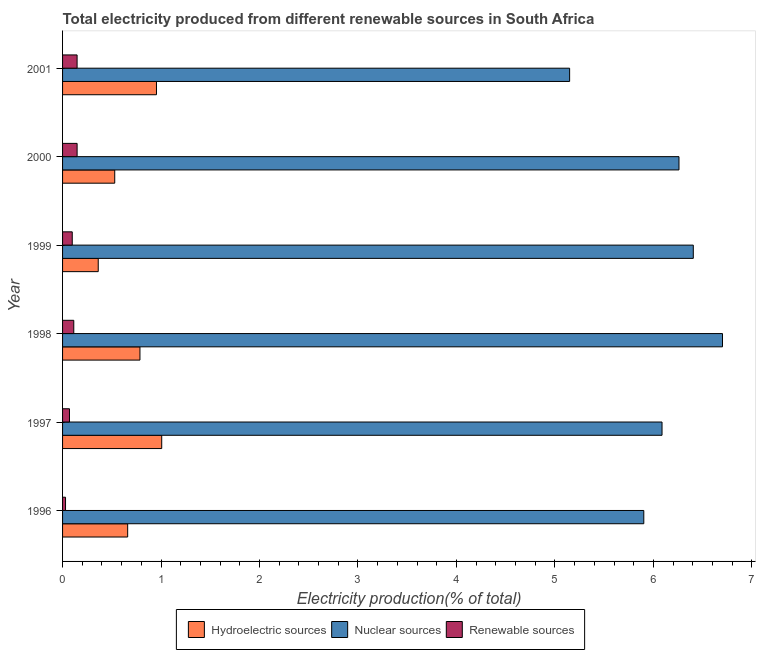How many different coloured bars are there?
Provide a succinct answer. 3. How many groups of bars are there?
Your response must be concise. 6. Are the number of bars per tick equal to the number of legend labels?
Provide a succinct answer. Yes. Are the number of bars on each tick of the Y-axis equal?
Provide a succinct answer. Yes. How many bars are there on the 4th tick from the top?
Provide a succinct answer. 3. What is the percentage of electricity produced by renewable sources in 1999?
Offer a very short reply. 0.1. Across all years, what is the maximum percentage of electricity produced by renewable sources?
Offer a terse response. 0.15. Across all years, what is the minimum percentage of electricity produced by renewable sources?
Offer a terse response. 0.03. In which year was the percentage of electricity produced by renewable sources minimum?
Keep it short and to the point. 1996. What is the total percentage of electricity produced by nuclear sources in the graph?
Your answer should be very brief. 36.51. What is the difference between the percentage of electricity produced by nuclear sources in 1998 and that in 2000?
Ensure brevity in your answer.  0.44. What is the difference between the percentage of electricity produced by renewable sources in 1997 and the percentage of electricity produced by hydroelectric sources in 1999?
Your response must be concise. -0.29. What is the average percentage of electricity produced by renewable sources per year?
Keep it short and to the point. 0.1. In the year 2000, what is the difference between the percentage of electricity produced by nuclear sources and percentage of electricity produced by renewable sources?
Ensure brevity in your answer.  6.11. What is the ratio of the percentage of electricity produced by hydroelectric sources in 1996 to that in 2000?
Offer a terse response. 1.25. Is the difference between the percentage of electricity produced by hydroelectric sources in 1996 and 1998 greater than the difference between the percentage of electricity produced by nuclear sources in 1996 and 1998?
Make the answer very short. Yes. What is the difference between the highest and the second highest percentage of electricity produced by hydroelectric sources?
Keep it short and to the point. 0.05. What is the difference between the highest and the lowest percentage of electricity produced by renewable sources?
Keep it short and to the point. 0.12. What does the 2nd bar from the top in 1997 represents?
Keep it short and to the point. Nuclear sources. What does the 1st bar from the bottom in 1997 represents?
Your answer should be compact. Hydroelectric sources. Is it the case that in every year, the sum of the percentage of electricity produced by hydroelectric sources and percentage of electricity produced by nuclear sources is greater than the percentage of electricity produced by renewable sources?
Offer a very short reply. Yes. What is the difference between two consecutive major ticks on the X-axis?
Keep it short and to the point. 1. Are the values on the major ticks of X-axis written in scientific E-notation?
Provide a succinct answer. No. How are the legend labels stacked?
Offer a very short reply. Horizontal. What is the title of the graph?
Provide a short and direct response. Total electricity produced from different renewable sources in South Africa. What is the label or title of the X-axis?
Provide a succinct answer. Electricity production(% of total). What is the label or title of the Y-axis?
Make the answer very short. Year. What is the Electricity production(% of total) of Hydroelectric sources in 1996?
Your response must be concise. 0.66. What is the Electricity production(% of total) in Nuclear sources in 1996?
Offer a terse response. 5.9. What is the Electricity production(% of total) in Renewable sources in 1996?
Keep it short and to the point. 0.03. What is the Electricity production(% of total) in Hydroelectric sources in 1997?
Make the answer very short. 1.01. What is the Electricity production(% of total) of Nuclear sources in 1997?
Your answer should be compact. 6.09. What is the Electricity production(% of total) in Renewable sources in 1997?
Your answer should be compact. 0.07. What is the Electricity production(% of total) in Hydroelectric sources in 1998?
Offer a very short reply. 0.79. What is the Electricity production(% of total) of Nuclear sources in 1998?
Provide a short and direct response. 6.7. What is the Electricity production(% of total) of Renewable sources in 1998?
Offer a terse response. 0.11. What is the Electricity production(% of total) of Hydroelectric sources in 1999?
Provide a succinct answer. 0.36. What is the Electricity production(% of total) of Nuclear sources in 1999?
Provide a short and direct response. 6.4. What is the Electricity production(% of total) of Renewable sources in 1999?
Keep it short and to the point. 0.1. What is the Electricity production(% of total) in Hydroelectric sources in 2000?
Offer a terse response. 0.53. What is the Electricity production(% of total) of Nuclear sources in 2000?
Offer a terse response. 6.26. What is the Electricity production(% of total) in Renewable sources in 2000?
Provide a short and direct response. 0.15. What is the Electricity production(% of total) of Hydroelectric sources in 2001?
Your answer should be very brief. 0.95. What is the Electricity production(% of total) in Nuclear sources in 2001?
Give a very brief answer. 5.15. What is the Electricity production(% of total) of Renewable sources in 2001?
Your answer should be very brief. 0.15. Across all years, what is the maximum Electricity production(% of total) in Hydroelectric sources?
Provide a succinct answer. 1.01. Across all years, what is the maximum Electricity production(% of total) of Nuclear sources?
Your answer should be very brief. 6.7. Across all years, what is the maximum Electricity production(% of total) in Renewable sources?
Provide a succinct answer. 0.15. Across all years, what is the minimum Electricity production(% of total) of Hydroelectric sources?
Offer a very short reply. 0.36. Across all years, what is the minimum Electricity production(% of total) in Nuclear sources?
Make the answer very short. 5.15. Across all years, what is the minimum Electricity production(% of total) in Renewable sources?
Give a very brief answer. 0.03. What is the total Electricity production(% of total) of Hydroelectric sources in the graph?
Your response must be concise. 4.3. What is the total Electricity production(% of total) of Nuclear sources in the graph?
Offer a very short reply. 36.51. What is the total Electricity production(% of total) of Renewable sources in the graph?
Make the answer very short. 0.61. What is the difference between the Electricity production(% of total) in Hydroelectric sources in 1996 and that in 1997?
Provide a succinct answer. -0.35. What is the difference between the Electricity production(% of total) of Nuclear sources in 1996 and that in 1997?
Provide a succinct answer. -0.19. What is the difference between the Electricity production(% of total) in Renewable sources in 1996 and that in 1997?
Keep it short and to the point. -0.04. What is the difference between the Electricity production(% of total) in Hydroelectric sources in 1996 and that in 1998?
Your response must be concise. -0.12. What is the difference between the Electricity production(% of total) in Nuclear sources in 1996 and that in 1998?
Give a very brief answer. -0.8. What is the difference between the Electricity production(% of total) in Renewable sources in 1996 and that in 1998?
Your answer should be compact. -0.08. What is the difference between the Electricity production(% of total) in Hydroelectric sources in 1996 and that in 1999?
Make the answer very short. 0.3. What is the difference between the Electricity production(% of total) in Nuclear sources in 1996 and that in 1999?
Make the answer very short. -0.5. What is the difference between the Electricity production(% of total) in Renewable sources in 1996 and that in 1999?
Your answer should be very brief. -0.07. What is the difference between the Electricity production(% of total) of Hydroelectric sources in 1996 and that in 2000?
Make the answer very short. 0.13. What is the difference between the Electricity production(% of total) in Nuclear sources in 1996 and that in 2000?
Offer a terse response. -0.36. What is the difference between the Electricity production(% of total) of Renewable sources in 1996 and that in 2000?
Your response must be concise. -0.12. What is the difference between the Electricity production(% of total) in Hydroelectric sources in 1996 and that in 2001?
Your answer should be very brief. -0.29. What is the difference between the Electricity production(% of total) in Nuclear sources in 1996 and that in 2001?
Provide a succinct answer. 0.75. What is the difference between the Electricity production(% of total) of Renewable sources in 1996 and that in 2001?
Offer a very short reply. -0.12. What is the difference between the Electricity production(% of total) of Hydroelectric sources in 1997 and that in 1998?
Provide a short and direct response. 0.22. What is the difference between the Electricity production(% of total) in Nuclear sources in 1997 and that in 1998?
Keep it short and to the point. -0.61. What is the difference between the Electricity production(% of total) of Renewable sources in 1997 and that in 1998?
Your answer should be compact. -0.04. What is the difference between the Electricity production(% of total) of Hydroelectric sources in 1997 and that in 1999?
Keep it short and to the point. 0.64. What is the difference between the Electricity production(% of total) of Nuclear sources in 1997 and that in 1999?
Provide a succinct answer. -0.32. What is the difference between the Electricity production(% of total) of Renewable sources in 1997 and that in 1999?
Provide a short and direct response. -0.03. What is the difference between the Electricity production(% of total) of Hydroelectric sources in 1997 and that in 2000?
Provide a succinct answer. 0.48. What is the difference between the Electricity production(% of total) of Nuclear sources in 1997 and that in 2000?
Ensure brevity in your answer.  -0.17. What is the difference between the Electricity production(% of total) in Renewable sources in 1997 and that in 2000?
Offer a terse response. -0.08. What is the difference between the Electricity production(% of total) of Hydroelectric sources in 1997 and that in 2001?
Give a very brief answer. 0.05. What is the difference between the Electricity production(% of total) of Nuclear sources in 1997 and that in 2001?
Your answer should be very brief. 0.94. What is the difference between the Electricity production(% of total) of Renewable sources in 1997 and that in 2001?
Offer a terse response. -0.08. What is the difference between the Electricity production(% of total) in Hydroelectric sources in 1998 and that in 1999?
Offer a terse response. 0.42. What is the difference between the Electricity production(% of total) in Nuclear sources in 1998 and that in 1999?
Give a very brief answer. 0.3. What is the difference between the Electricity production(% of total) of Renewable sources in 1998 and that in 1999?
Ensure brevity in your answer.  0.02. What is the difference between the Electricity production(% of total) of Hydroelectric sources in 1998 and that in 2000?
Your response must be concise. 0.26. What is the difference between the Electricity production(% of total) in Nuclear sources in 1998 and that in 2000?
Your response must be concise. 0.44. What is the difference between the Electricity production(% of total) in Renewable sources in 1998 and that in 2000?
Your response must be concise. -0.03. What is the difference between the Electricity production(% of total) in Hydroelectric sources in 1998 and that in 2001?
Offer a very short reply. -0.17. What is the difference between the Electricity production(% of total) in Nuclear sources in 1998 and that in 2001?
Give a very brief answer. 1.55. What is the difference between the Electricity production(% of total) in Renewable sources in 1998 and that in 2001?
Your answer should be compact. -0.03. What is the difference between the Electricity production(% of total) in Hydroelectric sources in 1999 and that in 2000?
Your answer should be very brief. -0.17. What is the difference between the Electricity production(% of total) in Nuclear sources in 1999 and that in 2000?
Offer a terse response. 0.15. What is the difference between the Electricity production(% of total) in Renewable sources in 1999 and that in 2000?
Keep it short and to the point. -0.05. What is the difference between the Electricity production(% of total) of Hydroelectric sources in 1999 and that in 2001?
Offer a terse response. -0.59. What is the difference between the Electricity production(% of total) in Nuclear sources in 1999 and that in 2001?
Give a very brief answer. 1.26. What is the difference between the Electricity production(% of total) in Renewable sources in 1999 and that in 2001?
Your answer should be compact. -0.05. What is the difference between the Electricity production(% of total) of Hydroelectric sources in 2000 and that in 2001?
Keep it short and to the point. -0.42. What is the difference between the Electricity production(% of total) of Nuclear sources in 2000 and that in 2001?
Offer a terse response. 1.11. What is the difference between the Electricity production(% of total) of Renewable sources in 2000 and that in 2001?
Your response must be concise. 0. What is the difference between the Electricity production(% of total) in Hydroelectric sources in 1996 and the Electricity production(% of total) in Nuclear sources in 1997?
Your response must be concise. -5.43. What is the difference between the Electricity production(% of total) in Hydroelectric sources in 1996 and the Electricity production(% of total) in Renewable sources in 1997?
Your answer should be very brief. 0.59. What is the difference between the Electricity production(% of total) in Nuclear sources in 1996 and the Electricity production(% of total) in Renewable sources in 1997?
Your answer should be very brief. 5.83. What is the difference between the Electricity production(% of total) of Hydroelectric sources in 1996 and the Electricity production(% of total) of Nuclear sources in 1998?
Provide a succinct answer. -6.04. What is the difference between the Electricity production(% of total) in Hydroelectric sources in 1996 and the Electricity production(% of total) in Renewable sources in 1998?
Provide a succinct answer. 0.55. What is the difference between the Electricity production(% of total) of Nuclear sources in 1996 and the Electricity production(% of total) of Renewable sources in 1998?
Provide a short and direct response. 5.79. What is the difference between the Electricity production(% of total) in Hydroelectric sources in 1996 and the Electricity production(% of total) in Nuclear sources in 1999?
Make the answer very short. -5.74. What is the difference between the Electricity production(% of total) of Hydroelectric sources in 1996 and the Electricity production(% of total) of Renewable sources in 1999?
Your answer should be compact. 0.56. What is the difference between the Electricity production(% of total) of Nuclear sources in 1996 and the Electricity production(% of total) of Renewable sources in 1999?
Provide a short and direct response. 5.8. What is the difference between the Electricity production(% of total) of Hydroelectric sources in 1996 and the Electricity production(% of total) of Nuclear sources in 2000?
Your answer should be compact. -5.6. What is the difference between the Electricity production(% of total) of Hydroelectric sources in 1996 and the Electricity production(% of total) of Renewable sources in 2000?
Your response must be concise. 0.51. What is the difference between the Electricity production(% of total) in Nuclear sources in 1996 and the Electricity production(% of total) in Renewable sources in 2000?
Offer a very short reply. 5.75. What is the difference between the Electricity production(% of total) in Hydroelectric sources in 1996 and the Electricity production(% of total) in Nuclear sources in 2001?
Your response must be concise. -4.49. What is the difference between the Electricity production(% of total) of Hydroelectric sources in 1996 and the Electricity production(% of total) of Renewable sources in 2001?
Keep it short and to the point. 0.51. What is the difference between the Electricity production(% of total) in Nuclear sources in 1996 and the Electricity production(% of total) in Renewable sources in 2001?
Offer a terse response. 5.75. What is the difference between the Electricity production(% of total) in Hydroelectric sources in 1997 and the Electricity production(% of total) in Nuclear sources in 1998?
Ensure brevity in your answer.  -5.69. What is the difference between the Electricity production(% of total) of Hydroelectric sources in 1997 and the Electricity production(% of total) of Renewable sources in 1998?
Make the answer very short. 0.89. What is the difference between the Electricity production(% of total) in Nuclear sources in 1997 and the Electricity production(% of total) in Renewable sources in 1998?
Your answer should be compact. 5.97. What is the difference between the Electricity production(% of total) in Hydroelectric sources in 1997 and the Electricity production(% of total) in Nuclear sources in 1999?
Give a very brief answer. -5.4. What is the difference between the Electricity production(% of total) in Hydroelectric sources in 1997 and the Electricity production(% of total) in Renewable sources in 1999?
Offer a very short reply. 0.91. What is the difference between the Electricity production(% of total) in Nuclear sources in 1997 and the Electricity production(% of total) in Renewable sources in 1999?
Provide a short and direct response. 5.99. What is the difference between the Electricity production(% of total) of Hydroelectric sources in 1997 and the Electricity production(% of total) of Nuclear sources in 2000?
Provide a succinct answer. -5.25. What is the difference between the Electricity production(% of total) in Hydroelectric sources in 1997 and the Electricity production(% of total) in Renewable sources in 2000?
Your answer should be very brief. 0.86. What is the difference between the Electricity production(% of total) of Nuclear sources in 1997 and the Electricity production(% of total) of Renewable sources in 2000?
Give a very brief answer. 5.94. What is the difference between the Electricity production(% of total) of Hydroelectric sources in 1997 and the Electricity production(% of total) of Nuclear sources in 2001?
Keep it short and to the point. -4.14. What is the difference between the Electricity production(% of total) in Hydroelectric sources in 1997 and the Electricity production(% of total) in Renewable sources in 2001?
Make the answer very short. 0.86. What is the difference between the Electricity production(% of total) in Nuclear sources in 1997 and the Electricity production(% of total) in Renewable sources in 2001?
Make the answer very short. 5.94. What is the difference between the Electricity production(% of total) in Hydroelectric sources in 1998 and the Electricity production(% of total) in Nuclear sources in 1999?
Ensure brevity in your answer.  -5.62. What is the difference between the Electricity production(% of total) in Hydroelectric sources in 1998 and the Electricity production(% of total) in Renewable sources in 1999?
Your answer should be compact. 0.69. What is the difference between the Electricity production(% of total) of Nuclear sources in 1998 and the Electricity production(% of total) of Renewable sources in 1999?
Provide a short and direct response. 6.6. What is the difference between the Electricity production(% of total) in Hydroelectric sources in 1998 and the Electricity production(% of total) in Nuclear sources in 2000?
Ensure brevity in your answer.  -5.47. What is the difference between the Electricity production(% of total) of Hydroelectric sources in 1998 and the Electricity production(% of total) of Renewable sources in 2000?
Give a very brief answer. 0.64. What is the difference between the Electricity production(% of total) of Nuclear sources in 1998 and the Electricity production(% of total) of Renewable sources in 2000?
Keep it short and to the point. 6.55. What is the difference between the Electricity production(% of total) in Hydroelectric sources in 1998 and the Electricity production(% of total) in Nuclear sources in 2001?
Ensure brevity in your answer.  -4.36. What is the difference between the Electricity production(% of total) of Hydroelectric sources in 1998 and the Electricity production(% of total) of Renewable sources in 2001?
Your answer should be compact. 0.64. What is the difference between the Electricity production(% of total) in Nuclear sources in 1998 and the Electricity production(% of total) in Renewable sources in 2001?
Your response must be concise. 6.55. What is the difference between the Electricity production(% of total) in Hydroelectric sources in 1999 and the Electricity production(% of total) in Nuclear sources in 2000?
Your answer should be compact. -5.9. What is the difference between the Electricity production(% of total) in Hydroelectric sources in 1999 and the Electricity production(% of total) in Renewable sources in 2000?
Your answer should be very brief. 0.21. What is the difference between the Electricity production(% of total) of Nuclear sources in 1999 and the Electricity production(% of total) of Renewable sources in 2000?
Make the answer very short. 6.26. What is the difference between the Electricity production(% of total) of Hydroelectric sources in 1999 and the Electricity production(% of total) of Nuclear sources in 2001?
Keep it short and to the point. -4.79. What is the difference between the Electricity production(% of total) in Hydroelectric sources in 1999 and the Electricity production(% of total) in Renewable sources in 2001?
Keep it short and to the point. 0.21. What is the difference between the Electricity production(% of total) in Nuclear sources in 1999 and the Electricity production(% of total) in Renewable sources in 2001?
Offer a terse response. 6.26. What is the difference between the Electricity production(% of total) of Hydroelectric sources in 2000 and the Electricity production(% of total) of Nuclear sources in 2001?
Offer a very short reply. -4.62. What is the difference between the Electricity production(% of total) in Hydroelectric sources in 2000 and the Electricity production(% of total) in Renewable sources in 2001?
Make the answer very short. 0.38. What is the difference between the Electricity production(% of total) of Nuclear sources in 2000 and the Electricity production(% of total) of Renewable sources in 2001?
Provide a succinct answer. 6.11. What is the average Electricity production(% of total) of Hydroelectric sources per year?
Make the answer very short. 0.72. What is the average Electricity production(% of total) of Nuclear sources per year?
Give a very brief answer. 6.08. What is the average Electricity production(% of total) of Renewable sources per year?
Offer a terse response. 0.1. In the year 1996, what is the difference between the Electricity production(% of total) of Hydroelectric sources and Electricity production(% of total) of Nuclear sources?
Provide a succinct answer. -5.24. In the year 1996, what is the difference between the Electricity production(% of total) of Hydroelectric sources and Electricity production(% of total) of Renewable sources?
Provide a short and direct response. 0.63. In the year 1996, what is the difference between the Electricity production(% of total) of Nuclear sources and Electricity production(% of total) of Renewable sources?
Give a very brief answer. 5.87. In the year 1997, what is the difference between the Electricity production(% of total) of Hydroelectric sources and Electricity production(% of total) of Nuclear sources?
Provide a succinct answer. -5.08. In the year 1997, what is the difference between the Electricity production(% of total) of Hydroelectric sources and Electricity production(% of total) of Renewable sources?
Your answer should be very brief. 0.94. In the year 1997, what is the difference between the Electricity production(% of total) in Nuclear sources and Electricity production(% of total) in Renewable sources?
Offer a terse response. 6.02. In the year 1998, what is the difference between the Electricity production(% of total) of Hydroelectric sources and Electricity production(% of total) of Nuclear sources?
Give a very brief answer. -5.92. In the year 1998, what is the difference between the Electricity production(% of total) of Hydroelectric sources and Electricity production(% of total) of Renewable sources?
Ensure brevity in your answer.  0.67. In the year 1998, what is the difference between the Electricity production(% of total) in Nuclear sources and Electricity production(% of total) in Renewable sources?
Provide a short and direct response. 6.59. In the year 1999, what is the difference between the Electricity production(% of total) in Hydroelectric sources and Electricity production(% of total) in Nuclear sources?
Offer a very short reply. -6.04. In the year 1999, what is the difference between the Electricity production(% of total) in Hydroelectric sources and Electricity production(% of total) in Renewable sources?
Your answer should be very brief. 0.26. In the year 1999, what is the difference between the Electricity production(% of total) in Nuclear sources and Electricity production(% of total) in Renewable sources?
Offer a very short reply. 6.31. In the year 2000, what is the difference between the Electricity production(% of total) in Hydroelectric sources and Electricity production(% of total) in Nuclear sources?
Your answer should be very brief. -5.73. In the year 2000, what is the difference between the Electricity production(% of total) in Hydroelectric sources and Electricity production(% of total) in Renewable sources?
Provide a succinct answer. 0.38. In the year 2000, what is the difference between the Electricity production(% of total) of Nuclear sources and Electricity production(% of total) of Renewable sources?
Provide a short and direct response. 6.11. In the year 2001, what is the difference between the Electricity production(% of total) in Hydroelectric sources and Electricity production(% of total) in Nuclear sources?
Provide a succinct answer. -4.2. In the year 2001, what is the difference between the Electricity production(% of total) in Hydroelectric sources and Electricity production(% of total) in Renewable sources?
Your answer should be compact. 0.81. In the year 2001, what is the difference between the Electricity production(% of total) in Nuclear sources and Electricity production(% of total) in Renewable sources?
Offer a terse response. 5. What is the ratio of the Electricity production(% of total) in Hydroelectric sources in 1996 to that in 1997?
Ensure brevity in your answer.  0.66. What is the ratio of the Electricity production(% of total) of Nuclear sources in 1996 to that in 1997?
Keep it short and to the point. 0.97. What is the ratio of the Electricity production(% of total) of Renewable sources in 1996 to that in 1997?
Offer a terse response. 0.43. What is the ratio of the Electricity production(% of total) of Hydroelectric sources in 1996 to that in 1998?
Keep it short and to the point. 0.84. What is the ratio of the Electricity production(% of total) of Nuclear sources in 1996 to that in 1998?
Keep it short and to the point. 0.88. What is the ratio of the Electricity production(% of total) of Renewable sources in 1996 to that in 1998?
Your answer should be very brief. 0.26. What is the ratio of the Electricity production(% of total) in Hydroelectric sources in 1996 to that in 1999?
Offer a terse response. 1.83. What is the ratio of the Electricity production(% of total) of Nuclear sources in 1996 to that in 1999?
Make the answer very short. 0.92. What is the ratio of the Electricity production(% of total) of Renewable sources in 1996 to that in 1999?
Your answer should be compact. 0.31. What is the ratio of the Electricity production(% of total) in Hydroelectric sources in 1996 to that in 2000?
Offer a very short reply. 1.25. What is the ratio of the Electricity production(% of total) of Nuclear sources in 1996 to that in 2000?
Offer a terse response. 0.94. What is the ratio of the Electricity production(% of total) in Renewable sources in 1996 to that in 2000?
Offer a terse response. 0.2. What is the ratio of the Electricity production(% of total) in Hydroelectric sources in 1996 to that in 2001?
Your answer should be compact. 0.69. What is the ratio of the Electricity production(% of total) of Nuclear sources in 1996 to that in 2001?
Give a very brief answer. 1.15. What is the ratio of the Electricity production(% of total) in Renewable sources in 1996 to that in 2001?
Your answer should be very brief. 0.2. What is the ratio of the Electricity production(% of total) in Hydroelectric sources in 1997 to that in 1998?
Keep it short and to the point. 1.28. What is the ratio of the Electricity production(% of total) of Nuclear sources in 1997 to that in 1998?
Keep it short and to the point. 0.91. What is the ratio of the Electricity production(% of total) of Renewable sources in 1997 to that in 1998?
Provide a short and direct response. 0.62. What is the ratio of the Electricity production(% of total) of Hydroelectric sources in 1997 to that in 1999?
Make the answer very short. 2.78. What is the ratio of the Electricity production(% of total) in Nuclear sources in 1997 to that in 1999?
Make the answer very short. 0.95. What is the ratio of the Electricity production(% of total) in Renewable sources in 1997 to that in 1999?
Make the answer very short. 0.71. What is the ratio of the Electricity production(% of total) of Hydroelectric sources in 1997 to that in 2000?
Provide a short and direct response. 1.9. What is the ratio of the Electricity production(% of total) in Nuclear sources in 1997 to that in 2000?
Your answer should be compact. 0.97. What is the ratio of the Electricity production(% of total) in Renewable sources in 1997 to that in 2000?
Make the answer very short. 0.48. What is the ratio of the Electricity production(% of total) of Hydroelectric sources in 1997 to that in 2001?
Keep it short and to the point. 1.06. What is the ratio of the Electricity production(% of total) in Nuclear sources in 1997 to that in 2001?
Offer a terse response. 1.18. What is the ratio of the Electricity production(% of total) of Renewable sources in 1997 to that in 2001?
Your response must be concise. 0.48. What is the ratio of the Electricity production(% of total) of Hydroelectric sources in 1998 to that in 1999?
Your response must be concise. 2.17. What is the ratio of the Electricity production(% of total) in Nuclear sources in 1998 to that in 1999?
Offer a very short reply. 1.05. What is the ratio of the Electricity production(% of total) of Renewable sources in 1998 to that in 1999?
Make the answer very short. 1.16. What is the ratio of the Electricity production(% of total) of Hydroelectric sources in 1998 to that in 2000?
Keep it short and to the point. 1.48. What is the ratio of the Electricity production(% of total) of Nuclear sources in 1998 to that in 2000?
Provide a succinct answer. 1.07. What is the ratio of the Electricity production(% of total) of Renewable sources in 1998 to that in 2000?
Give a very brief answer. 0.77. What is the ratio of the Electricity production(% of total) in Hydroelectric sources in 1998 to that in 2001?
Make the answer very short. 0.82. What is the ratio of the Electricity production(% of total) in Nuclear sources in 1998 to that in 2001?
Provide a succinct answer. 1.3. What is the ratio of the Electricity production(% of total) in Renewable sources in 1998 to that in 2001?
Offer a very short reply. 0.77. What is the ratio of the Electricity production(% of total) in Hydroelectric sources in 1999 to that in 2000?
Your answer should be very brief. 0.68. What is the ratio of the Electricity production(% of total) in Nuclear sources in 1999 to that in 2000?
Ensure brevity in your answer.  1.02. What is the ratio of the Electricity production(% of total) of Renewable sources in 1999 to that in 2000?
Offer a very short reply. 0.67. What is the ratio of the Electricity production(% of total) of Hydroelectric sources in 1999 to that in 2001?
Offer a very short reply. 0.38. What is the ratio of the Electricity production(% of total) of Nuclear sources in 1999 to that in 2001?
Make the answer very short. 1.24. What is the ratio of the Electricity production(% of total) of Renewable sources in 1999 to that in 2001?
Provide a short and direct response. 0.67. What is the ratio of the Electricity production(% of total) in Hydroelectric sources in 2000 to that in 2001?
Make the answer very short. 0.56. What is the ratio of the Electricity production(% of total) of Nuclear sources in 2000 to that in 2001?
Provide a short and direct response. 1.22. What is the difference between the highest and the second highest Electricity production(% of total) of Hydroelectric sources?
Your response must be concise. 0.05. What is the difference between the highest and the second highest Electricity production(% of total) of Nuclear sources?
Offer a terse response. 0.3. What is the difference between the highest and the second highest Electricity production(% of total) of Renewable sources?
Make the answer very short. 0. What is the difference between the highest and the lowest Electricity production(% of total) in Hydroelectric sources?
Offer a very short reply. 0.64. What is the difference between the highest and the lowest Electricity production(% of total) in Nuclear sources?
Provide a short and direct response. 1.55. What is the difference between the highest and the lowest Electricity production(% of total) in Renewable sources?
Your answer should be compact. 0.12. 